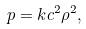Convert formula to latex. <formula><loc_0><loc_0><loc_500><loc_500>p = k c ^ { 2 } \rho ^ { 2 } ,</formula> 